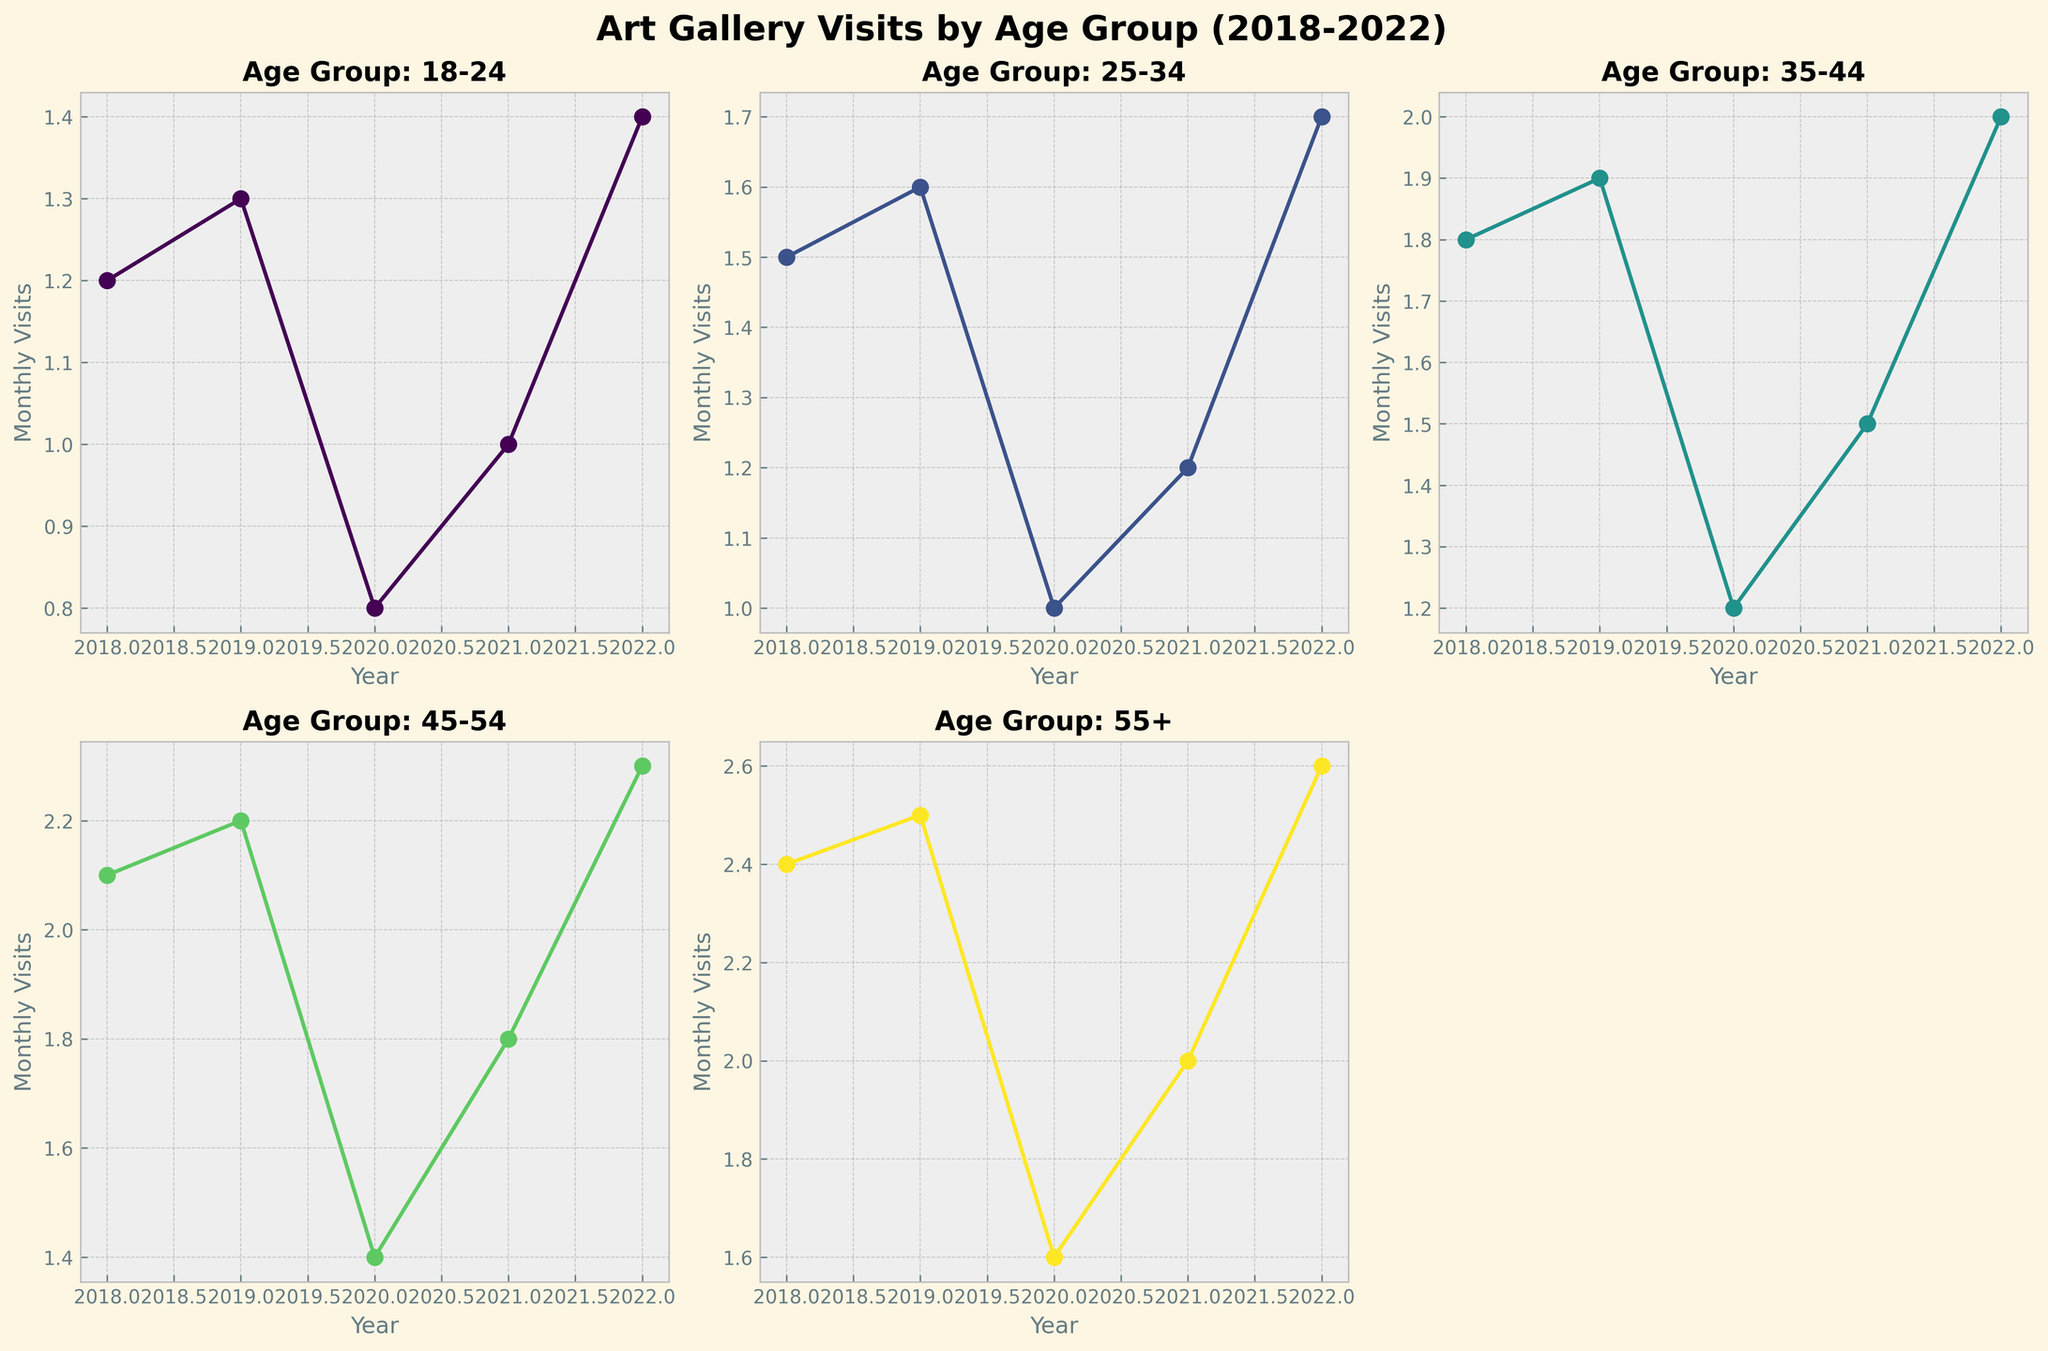What is the title of the figure? The title is displayed at the top-center of the figure and summarizes the content being plotted.
Answer: Art Gallery Visits by Age Group (2018-2022) Which age group had the highest monthly visits in 2022? By looking at the plot for the year 2022 across all subplots, we can see that the '55+' age group has the highest value.
Answer: 55+ How did the monthly visits for the 18-24 age group change from 2019 to 2020? Observing the subplot for the 18-24 age group, the line descends from 1.3 in 2019 to 0.8 in 2020. This indicates a decrease.
Answer: Decreased Which age group showed the largest decrease in monthly visits between 2019 and 2020? By comparing each subplot, we notice that the sharpest drop happens in the '55+' age group, going from 2.5 in 2019 to 1.6 in 2020, which is a decrease of 0.9 visits.
Answer: 55+ What is the average number of monthly visits for the 25-34 age group over the years? Add up the monthly visits for each year from 2018 to 2022 and divide by the total number of years (1.5+1.6+1.0+1.2+1.7) = 7/5 = 1.4.
Answer: 1.4 Which year had the lowest monthly visits for the 45-54 age group? Examine the plot for the 45-54 age group and identify the lowest point. In 2020, the value is 1.4, which is the lowest among the years.
Answer: 2020 How did the monthly visits for the 35-44 age group change from 2021 to 2022? Observing the subplot for the 35-44 age group, the line increases from 1.5 in 2021 to 2.0 in 2022. This indicates an increase.
Answer: Increased What is the overall trend in monthly visits for the 55+ age group? By evaluating the 55+ age group subplot, initially there is an increase till 2019, followed by a decrease in 2020 and then a gradual increase up to 2022.
Answer: Up, down, then up How do the monthly visits in 2019 compare between the 18-24 and 45-54 age groups? The subplot for 18-24 has a value of 1.3 in 2019, and the subplot for 45-54 has 2.2. Thus, the 45-54 group has higher visits.
Answer: 45-54 higher Between which years did the 25-34 age group see the smallest change in monthly visits? Check the line plot for the 25-34 age group and look for the smallest difference between consecutive years. From 2018 to 2019, the visits increase by just 0.1 (1.5 to 1.6), which is the smallest change.
Answer: 2018 to 2019 